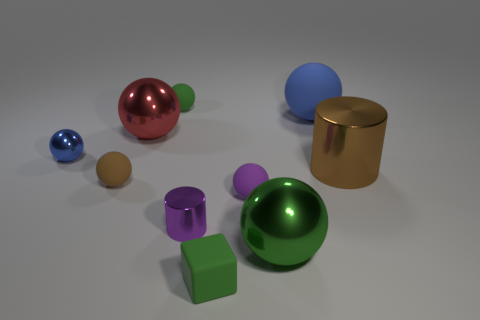What number of other things are there of the same size as the purple metallic thing?
Provide a succinct answer. 5. What number of objects are either tiny rubber spheres in front of the small green sphere or red objects?
Ensure brevity in your answer.  3. What color is the small metallic sphere?
Offer a very short reply. Blue. There is a blue thing behind the large red object; what is its material?
Keep it short and to the point. Rubber. There is a big red metallic thing; does it have the same shape as the tiny green thing that is behind the brown rubber object?
Give a very brief answer. Yes. Is the number of green rubber objects greater than the number of gray matte objects?
Make the answer very short. Yes. Is there anything else of the same color as the big matte sphere?
Your response must be concise. Yes. What shape is the big green thing that is made of the same material as the tiny blue ball?
Ensure brevity in your answer.  Sphere. There is a cylinder that is on the right side of the metal sphere that is right of the tiny cylinder; what is its material?
Your response must be concise. Metal. There is a blue object in front of the large blue matte ball; does it have the same shape as the big blue matte thing?
Offer a very short reply. Yes. 